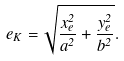Convert formula to latex. <formula><loc_0><loc_0><loc_500><loc_500>e _ { K } = \sqrt { \frac { x _ { e } ^ { 2 } } { a ^ { 2 } } + \frac { y _ { e } ^ { 2 } } { b ^ { 2 } } } .</formula> 